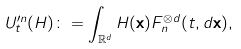<formula> <loc_0><loc_0><loc_500><loc_500>U _ { t } ^ { \prime n } ( H ) \colon = \int _ { \mathbb { R } ^ { d } } H ( \mathbf x ) F _ { n } ^ { \otimes d } ( t , d \mathbf x ) ,</formula> 